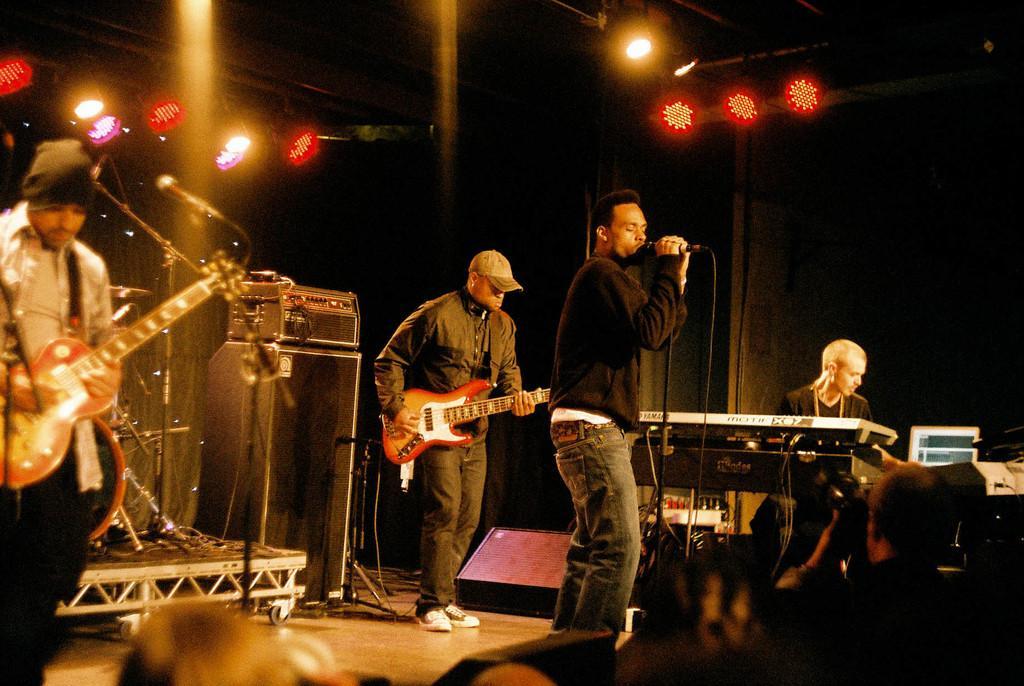Could you give a brief overview of what you see in this image? This is a picture taken in stage, there are three people standing on the stage and two people are performing the music. The man in black t shirt holding the microphone and singing a song. The other man is sitting on a chair and playing the piano. Background of this two is two people is a music systems and light. 